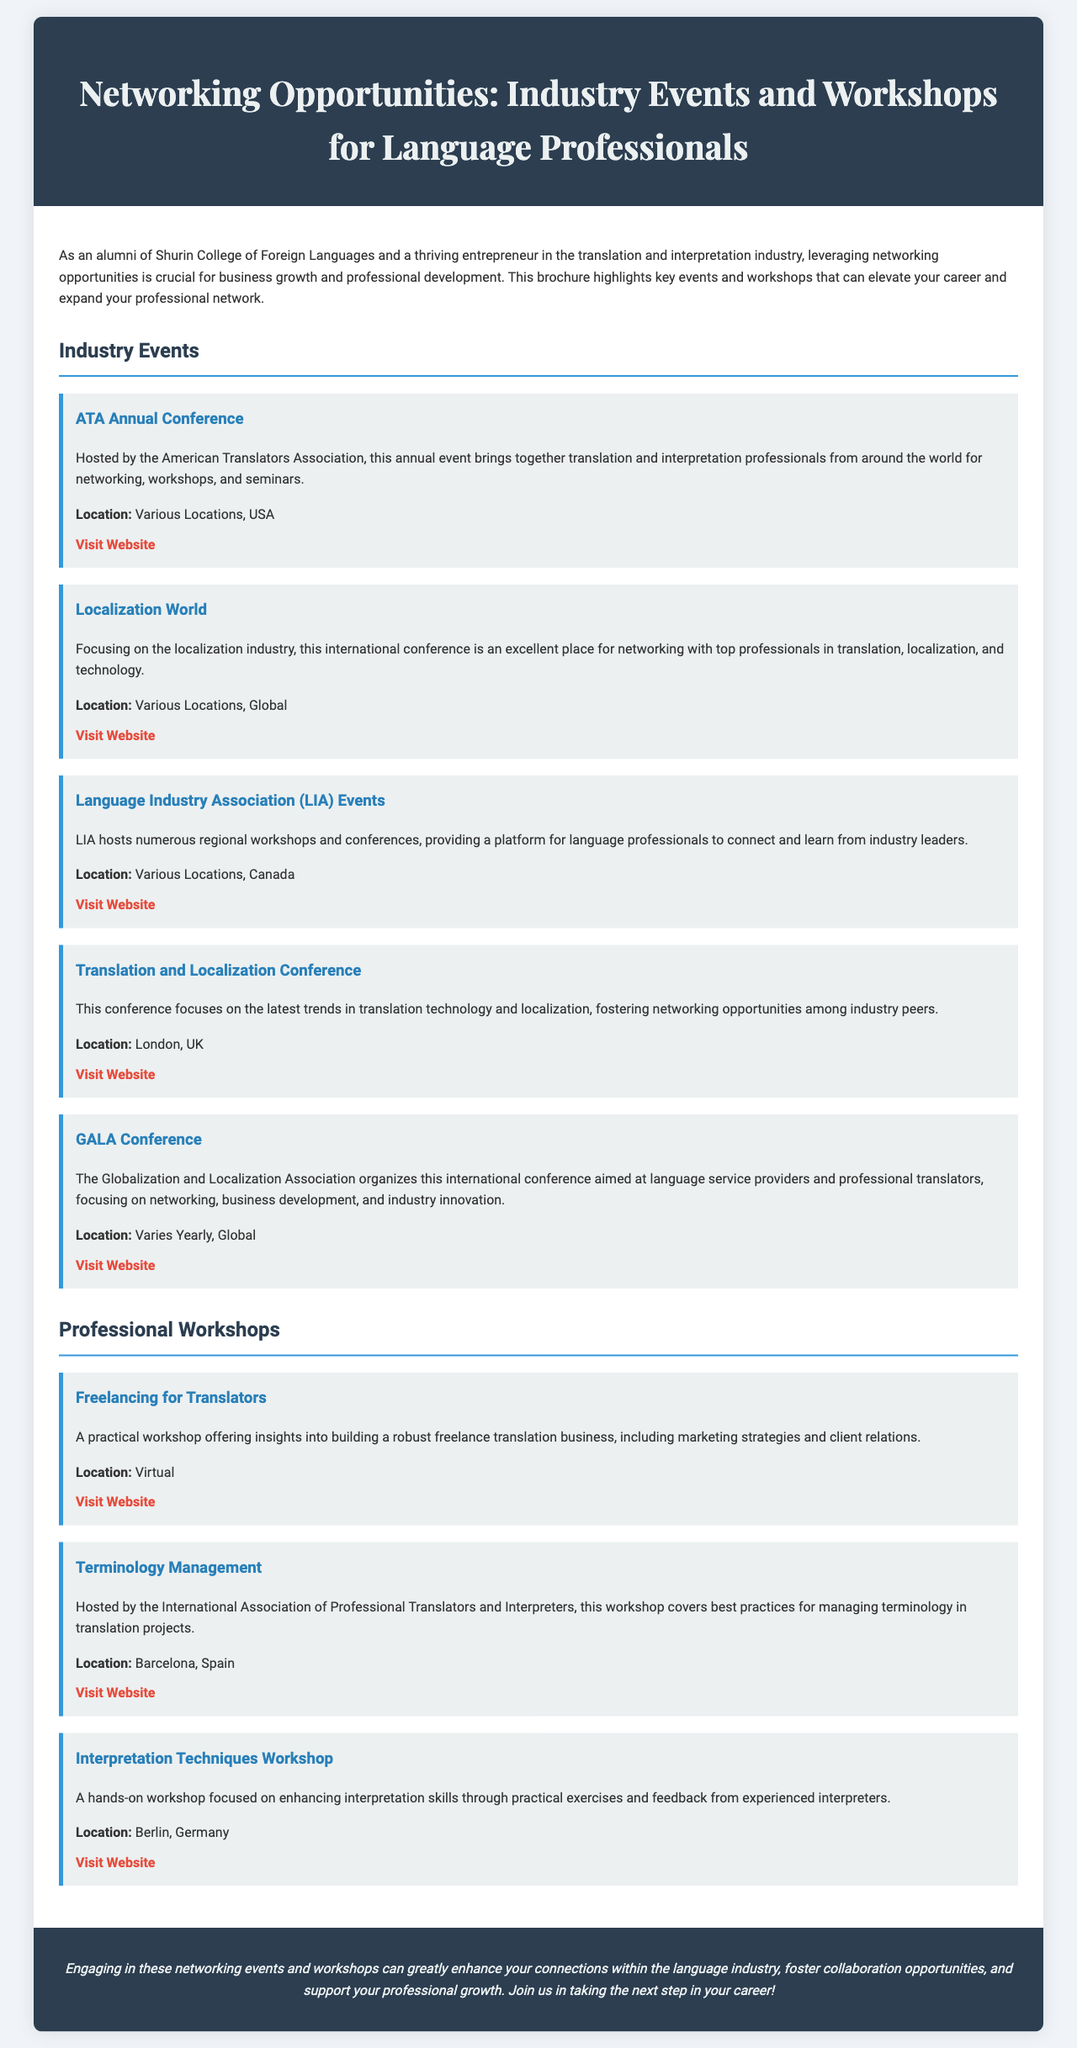What is the title of the brochure? The title of the brochure is prominently displayed in the header section, summarizing the main topic.
Answer: Networking Opportunities: Industry Events and Workshops for Language Professionals Who hosts the ATA Annual Conference? The brochure mentions that the conference is hosted by a specific association, identifying its organizer.
Answer: American Translators Association Where is the Localization World conference located? The document specifies the location category for this international event, providing clarity.
Answer: Various Locations, Global What topic does the "Freelancing for Translators" workshop cover? The description of the workshop provides insights into its primary focus and content.
Answer: Building a robust freelance translation business What is a benefit of attending these events and workshops? The closing statement of the brochure highlights the advantages of engagement in professional networking.
Answer: Enhance connections Which city hosts the "Interpretation Techniques Workshop"? The location of this specific workshop is provided in the description of the event.
Answer: Berlin, Germany What type of professionals does the GALA Conference target? The brochure notes the audience that this international conference aims to engage with, giving insight into the participants.
Answer: Language service providers and professional translators What is the website for the Terminology Management workshop? Each event is associated with a link for further information, allowing for easy access to details.
Answer: https://iatpi.org/ 